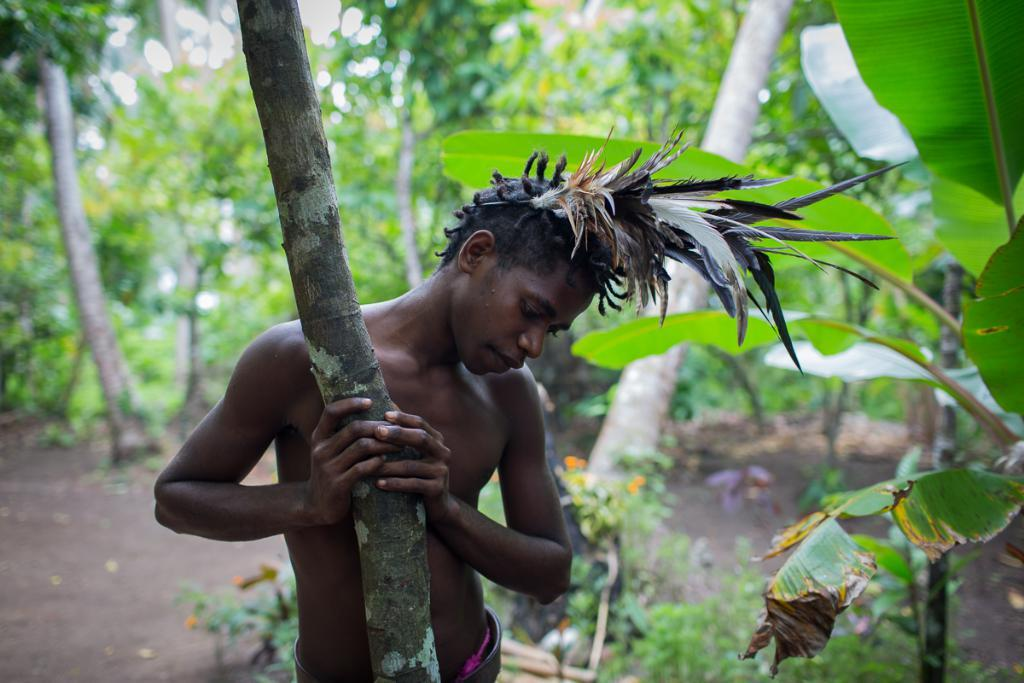What is the main subject of the image? There is a person in the image. What is the person wearing on their head? The person is wearing a crown made with feathers. What is the person holding in the image? The person is holding a tree. What can be seen in the background of the image? There are trees and plants in the background of the image. What type of flag is visible in the image? There is no flag present in the image. Is the person in the image taking a bath in a tub? There is no tub or indication of bathing in the image; the person is holding a tree. 